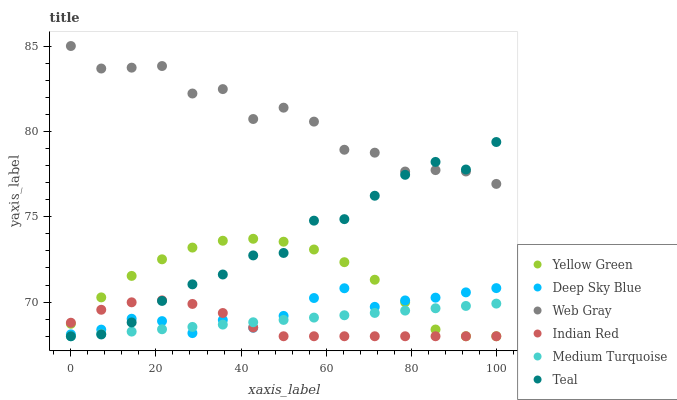Does Indian Red have the minimum area under the curve?
Answer yes or no. Yes. Does Web Gray have the maximum area under the curve?
Answer yes or no. Yes. Does Medium Turquoise have the minimum area under the curve?
Answer yes or no. No. Does Medium Turquoise have the maximum area under the curve?
Answer yes or no. No. Is Medium Turquoise the smoothest?
Answer yes or no. Yes. Is Web Gray the roughest?
Answer yes or no. Yes. Is Web Gray the smoothest?
Answer yes or no. No. Is Medium Turquoise the roughest?
Answer yes or no. No. Does Teal have the lowest value?
Answer yes or no. Yes. Does Web Gray have the lowest value?
Answer yes or no. No. Does Web Gray have the highest value?
Answer yes or no. Yes. Does Medium Turquoise have the highest value?
Answer yes or no. No. Is Indian Red less than Web Gray?
Answer yes or no. Yes. Is Web Gray greater than Yellow Green?
Answer yes or no. Yes. Does Deep Sky Blue intersect Indian Red?
Answer yes or no. Yes. Is Deep Sky Blue less than Indian Red?
Answer yes or no. No. Is Deep Sky Blue greater than Indian Red?
Answer yes or no. No. Does Indian Red intersect Web Gray?
Answer yes or no. No. 